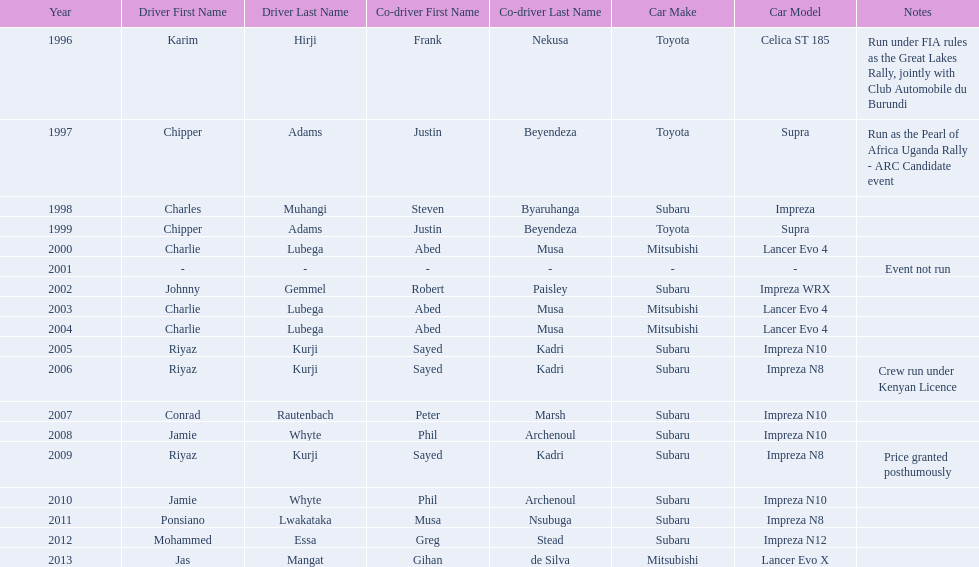Chipper adams and justin beyendeza have how mnay wins? 2. 